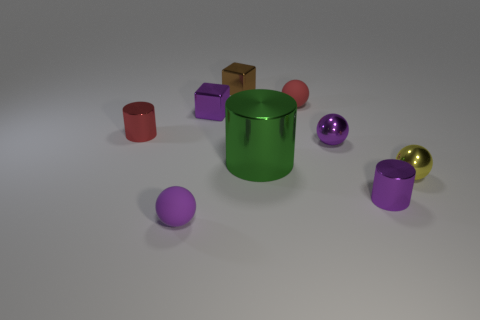Subtract all yellow metal spheres. How many spheres are left? 3 Add 1 brown cylinders. How many objects exist? 10 Subtract all yellow spheres. How many spheres are left? 3 Subtract all yellow blocks. How many purple spheres are left? 2 Subtract all cylinders. How many objects are left? 6 Subtract all red spheres. Subtract all red blocks. How many spheres are left? 3 Add 4 large green cylinders. How many large green cylinders are left? 5 Add 1 small purple metal balls. How many small purple metal balls exist? 2 Subtract 0 yellow blocks. How many objects are left? 9 Subtract all tiny brown objects. Subtract all tiny metal blocks. How many objects are left? 6 